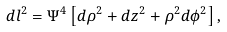Convert formula to latex. <formula><loc_0><loc_0><loc_500><loc_500>d l ^ { 2 } = \Psi ^ { 4 } \left [ d \rho ^ { 2 } + d z ^ { 2 } + \rho ^ { 2 } d \phi ^ { 2 } \right ] ,</formula> 